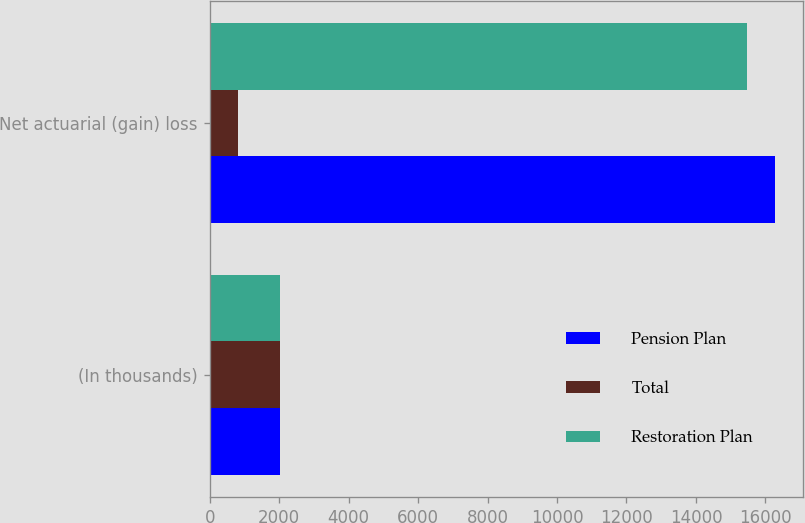Convert chart to OTSL. <chart><loc_0><loc_0><loc_500><loc_500><stacked_bar_chart><ecel><fcel>(In thousands)<fcel>Net actuarial (gain) loss<nl><fcel>Pension Plan<fcel>2014<fcel>16268<nl><fcel>Total<fcel>2014<fcel>803<nl><fcel>Restoration Plan<fcel>2014<fcel>15465<nl></chart> 